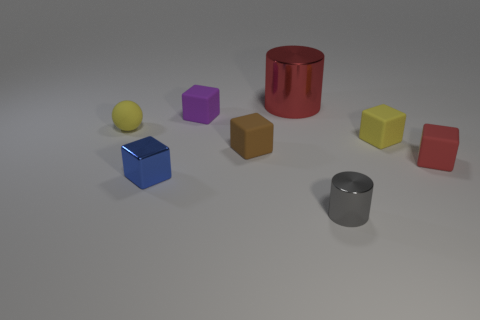There is a yellow thing that is right of the tiny cube that is in front of the red matte cube; is there a large cylinder that is to the right of it?
Provide a short and direct response. No. There is a tiny purple object; is its shape the same as the yellow rubber object on the left side of the gray thing?
Ensure brevity in your answer.  No. Are there any other things that have the same color as the shiny cube?
Offer a terse response. No. Is the color of the cylinder in front of the brown rubber object the same as the thing to the left of the tiny blue metallic thing?
Ensure brevity in your answer.  No. Is there a purple thing?
Your answer should be compact. Yes. Are there any large purple objects that have the same material as the blue block?
Ensure brevity in your answer.  No. Are there any other things that are the same material as the gray object?
Provide a succinct answer. Yes. The large cylinder has what color?
Make the answer very short. Red. What is the shape of the matte thing that is the same color as the large metallic cylinder?
Your response must be concise. Cube. What color is the rubber sphere that is the same size as the blue object?
Make the answer very short. Yellow. 